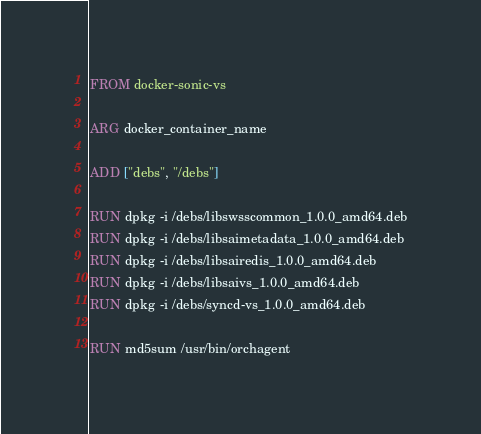<code> <loc_0><loc_0><loc_500><loc_500><_Dockerfile_>FROM docker-sonic-vs

ARG docker_container_name

ADD ["debs", "/debs"]

RUN dpkg -i /debs/libswsscommon_1.0.0_amd64.deb
RUN dpkg -i /debs/libsaimetadata_1.0.0_amd64.deb
RUN dpkg -i /debs/libsairedis_1.0.0_amd64.deb
RUN dpkg -i /debs/libsaivs_1.0.0_amd64.deb
RUN dpkg -i /debs/syncd-vs_1.0.0_amd64.deb

RUN md5sum /usr/bin/orchagent</code> 